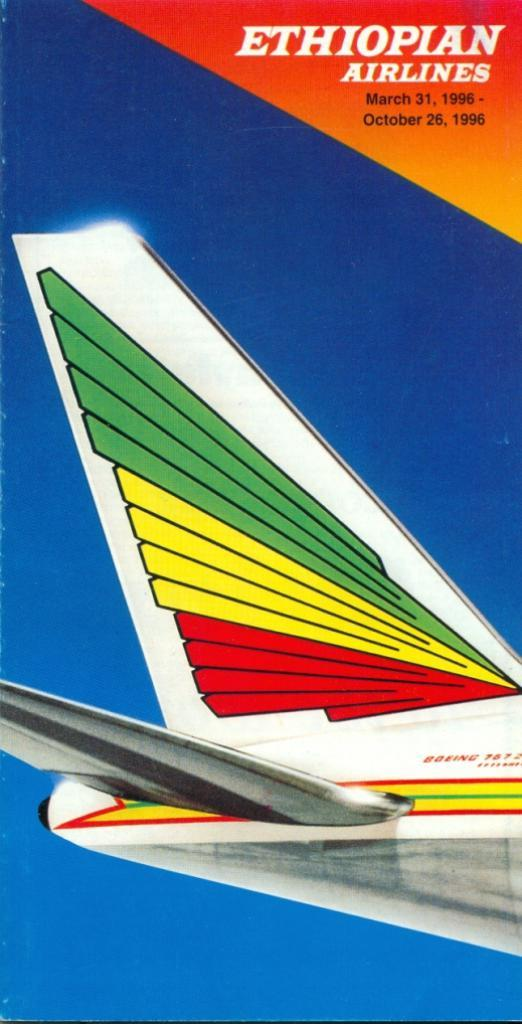<image>
Render a clear and concise summary of the photo. a poster for Ethiopian Airlines with a colorful tail of a plane 